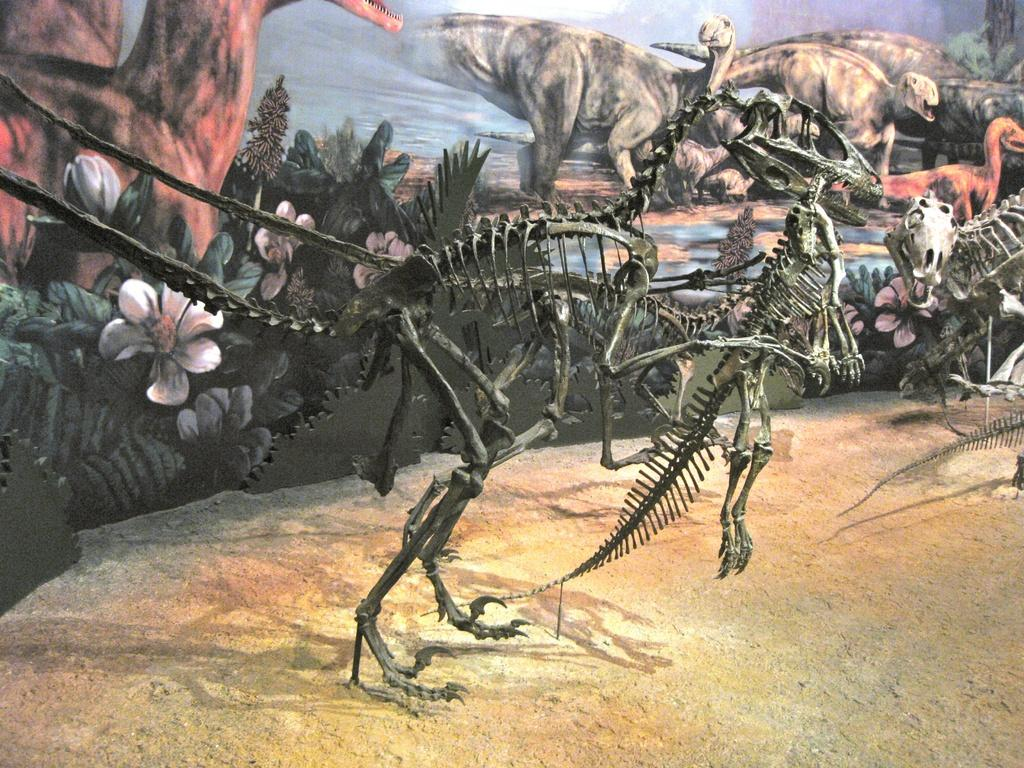What is the main subject of the picture? The main subject of the picture is a dinosaur, as there is a skeleton and a painting of a dinosaur in the picture. Can you describe the skeleton in the picture? The skeleton in the picture is that of a dinosaur. What else can be seen in the picture besides the dinosaur? There are plants visible in the picture. What type of toothpaste is being exchanged between the dinosaurs in the picture? There is no toothpaste or exchange of any kind depicted in the image; it features a dinosaur skeleton and a painting of a dinosaur with plants in the background. 